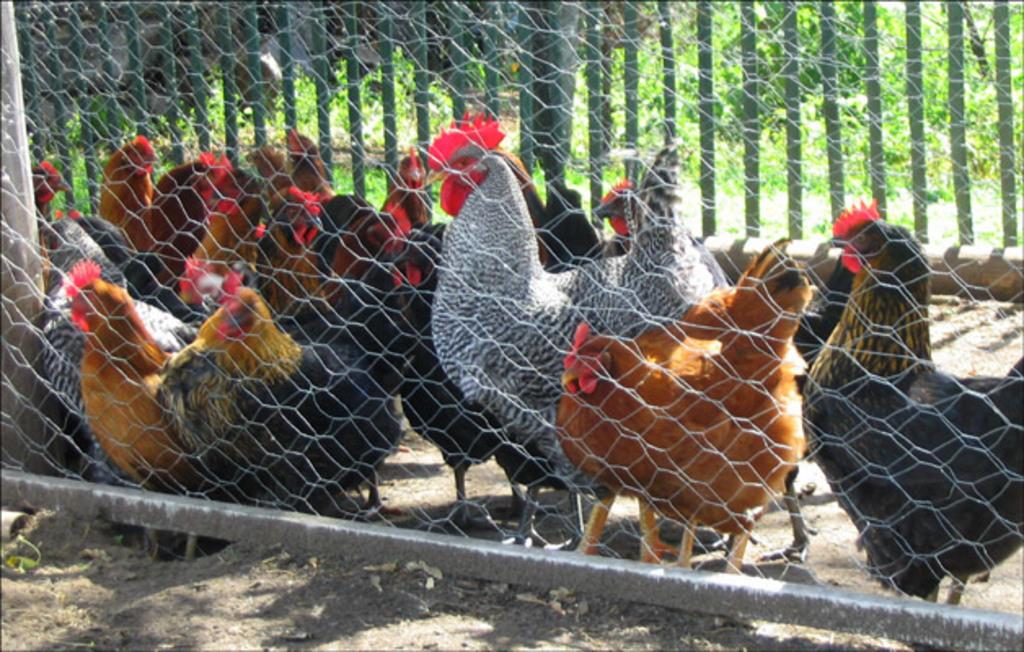What type of animals can be seen in the image? There are hens in the image. What is located in the foreground of the image? There is a mesh in the foreground of the image. What can be seen in the background of the image? There is a fence and grass in the background of the image. What religious belief is being expressed in the verse written on the wall in the image? There is no wall or verse present in the image; it features hens, a mesh, and a fence/grass. 